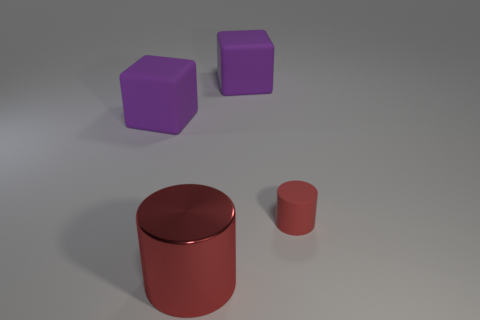What is the size of the shiny object?
Offer a terse response. Large. What is the shape of the rubber thing that is both behind the tiny red matte cylinder and to the right of the large shiny object?
Provide a short and direct response. Cube. How many cyan objects are either cubes or matte cylinders?
Your response must be concise. 0. There is a cylinder that is on the right side of the large red object; is its size the same as the cube right of the metallic cylinder?
Provide a short and direct response. No. How many things are small yellow blocks or red matte objects?
Ensure brevity in your answer.  1. Are there any small red matte objects that have the same shape as the big red thing?
Offer a terse response. Yes. Are there fewer rubber things than tiny blue shiny things?
Keep it short and to the point. No. Is the shape of the large red shiny object the same as the small matte object?
Your response must be concise. Yes. How many objects are purple rubber things or red cylinders behind the large cylinder?
Your response must be concise. 3. How many large matte blocks are there?
Your answer should be compact. 2. 